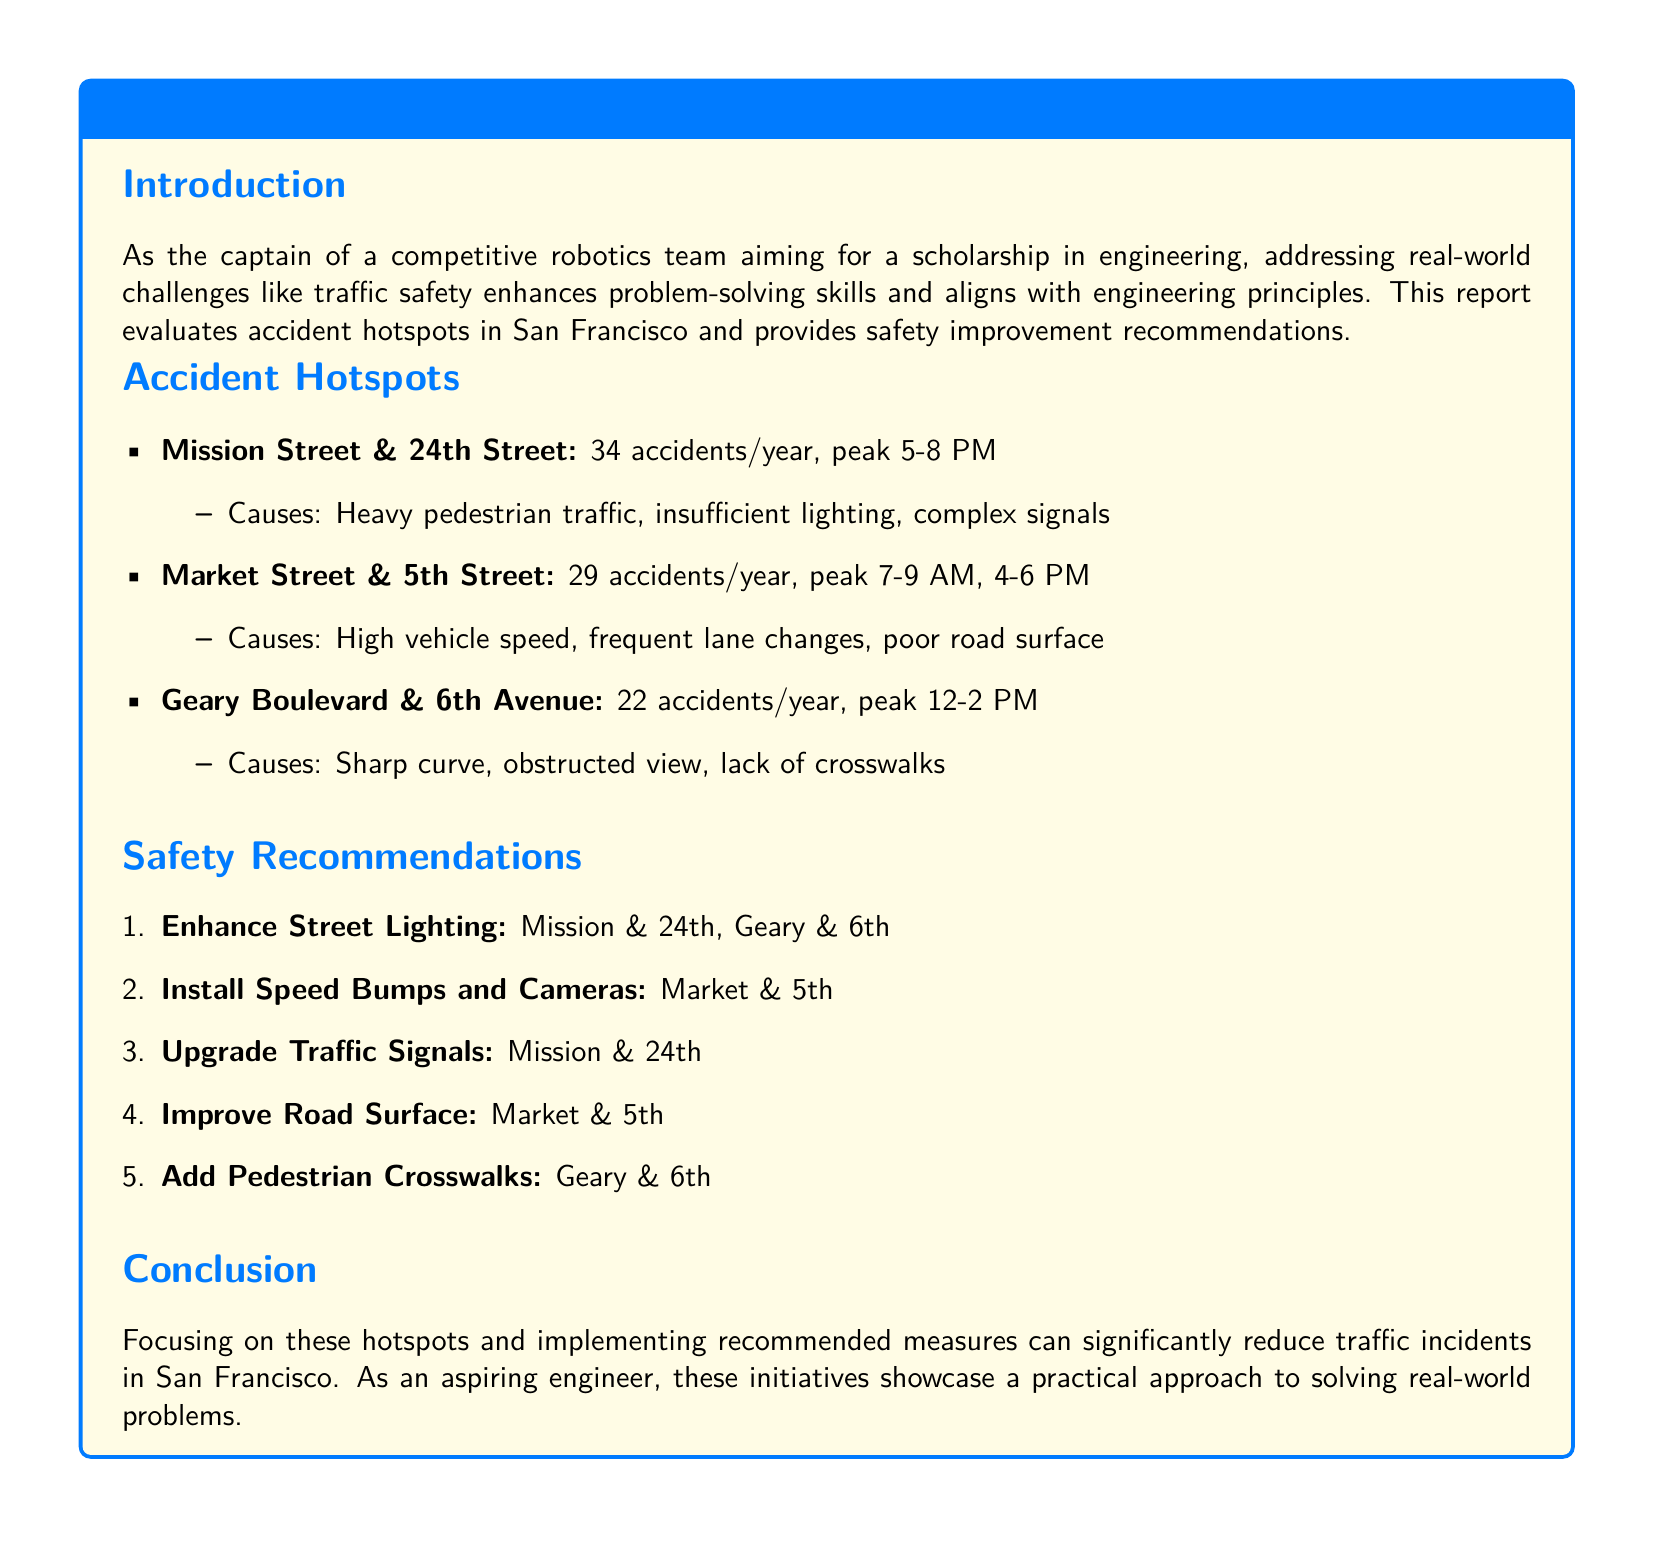What is the peak time for accidents at Mission and 24th? The peak time for accidents at this location is stated as 5-8 PM.
Answer: 5-8 PM How many accidents occur annually at Market and 5th? The document specifies that there are 29 accidents per year at Market and 5th.
Answer: 29 accidents/year What is one cause of accidents at Geary and 6th? The report lists the lack of crosswalks as one of the causes for accidents at this intersection.
Answer: Lack of crosswalks What safety measure is recommended for Mission and 24th? The document recommends upgrading the traffic signals for this location.
Answer: Upgrade Traffic Signals How many total hotspot locations are identified in the report? There are three accident hotspot locations mentioned in the document.
Answer: Three What is the primary cause of accidents at Market and 5th? The primary cause listed is high vehicle speed.
Answer: High vehicle speed Which recommendation involves adding physical features to the road? Installing speed bumps is a physical feature recommended for safety improvements.
Answer: Speed Bumps What is the total number of accidents reported per year across all hotspots? Total accidents are calculated as 34 + 29 + 22, which equals 85 accidents per year.
Answer: 85 accidents/year 